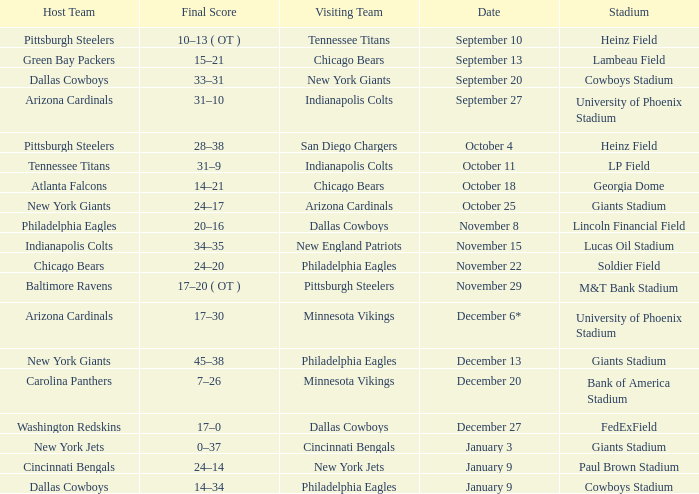Tell me the host team for giants stadium and visiting of cincinnati bengals New York Jets. 